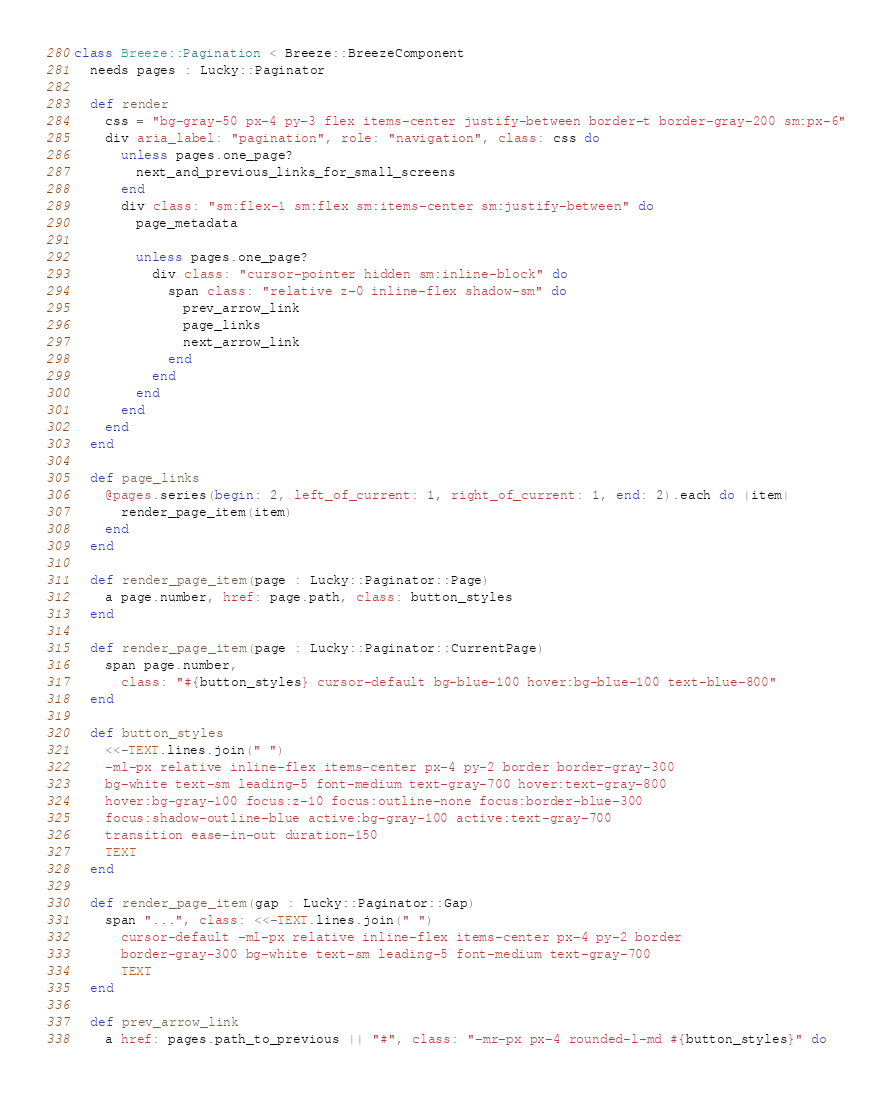<code> <loc_0><loc_0><loc_500><loc_500><_Crystal_>class Breeze::Pagination < Breeze::BreezeComponent
  needs pages : Lucky::Paginator

  def render
    css = "bg-gray-50 px-4 py-3 flex items-center justify-between border-t border-gray-200 sm:px-6"
    div aria_label: "pagination", role: "navigation", class: css do
      unless pages.one_page?
        next_and_previous_links_for_small_screens
      end
      div class: "sm:flex-1 sm:flex sm:items-center sm:justify-between" do
        page_metadata

        unless pages.one_page?
          div class: "cursor-pointer hidden sm:inline-block" do
            span class: "relative z-0 inline-flex shadow-sm" do
              prev_arrow_link
              page_links
              next_arrow_link
            end
          end
        end
      end
    end
  end

  def page_links
    @pages.series(begin: 2, left_of_current: 1, right_of_current: 1, end: 2).each do |item|
      render_page_item(item)
    end
  end

  def render_page_item(page : Lucky::Paginator::Page)
    a page.number, href: page.path, class: button_styles
  end

  def render_page_item(page : Lucky::Paginator::CurrentPage)
    span page.number,
      class: "#{button_styles} cursor-default bg-blue-100 hover:bg-blue-100 text-blue-800"
  end

  def button_styles
    <<-TEXT.lines.join(" ")
    -ml-px relative inline-flex items-center px-4 py-2 border border-gray-300
    bg-white text-sm leading-5 font-medium text-gray-700 hover:text-gray-800
    hover:bg-gray-100 focus:z-10 focus:outline-none focus:border-blue-300
    focus:shadow-outline-blue active:bg-gray-100 active:text-gray-700
    transition ease-in-out duration-150
    TEXT
  end

  def render_page_item(gap : Lucky::Paginator::Gap)
    span "...", class: <<-TEXT.lines.join(" ")
      cursor-default -ml-px relative inline-flex items-center px-4 py-2 border
      border-gray-300 bg-white text-sm leading-5 font-medium text-gray-700
      TEXT
  end

  def prev_arrow_link
    a href: pages.path_to_previous || "#", class: "-mr-px px-4 rounded-l-md #{button_styles}" do</code> 